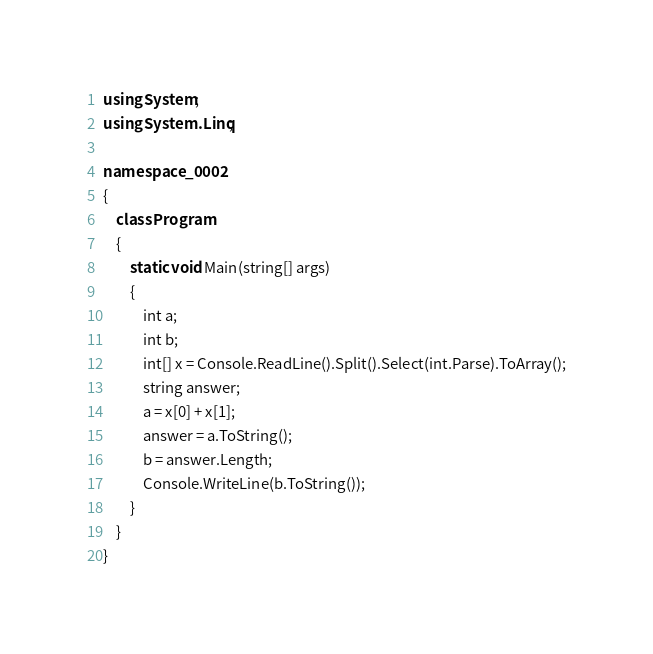Convert code to text. <code><loc_0><loc_0><loc_500><loc_500><_C#_>using System;
using System.Linq;

namespace _0002
{
    class Program
    {
        static void Main(string[] args)
        {
            int a;
            int b;
            int[] x = Console.ReadLine().Split().Select(int.Parse).ToArray();
            string answer;
            a = x[0] + x[1];
            answer = a.ToString();
            b = answer.Length;
            Console.WriteLine(b.ToString());
        }
    }
}</code> 